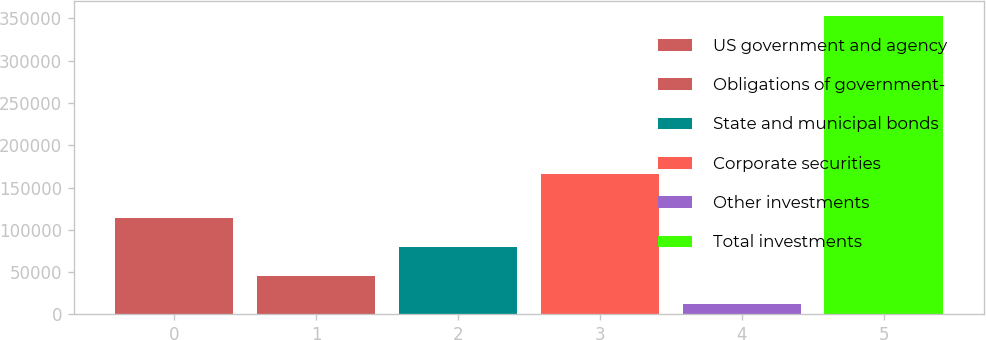<chart> <loc_0><loc_0><loc_500><loc_500><bar_chart><fcel>US government and agency<fcel>Obligations of government-<fcel>State and municipal bonds<fcel>Corporate securities<fcel>Other investments<fcel>Total investments<nl><fcel>114140<fcel>45903.3<fcel>80021.6<fcel>166420<fcel>11785<fcel>352968<nl></chart> 